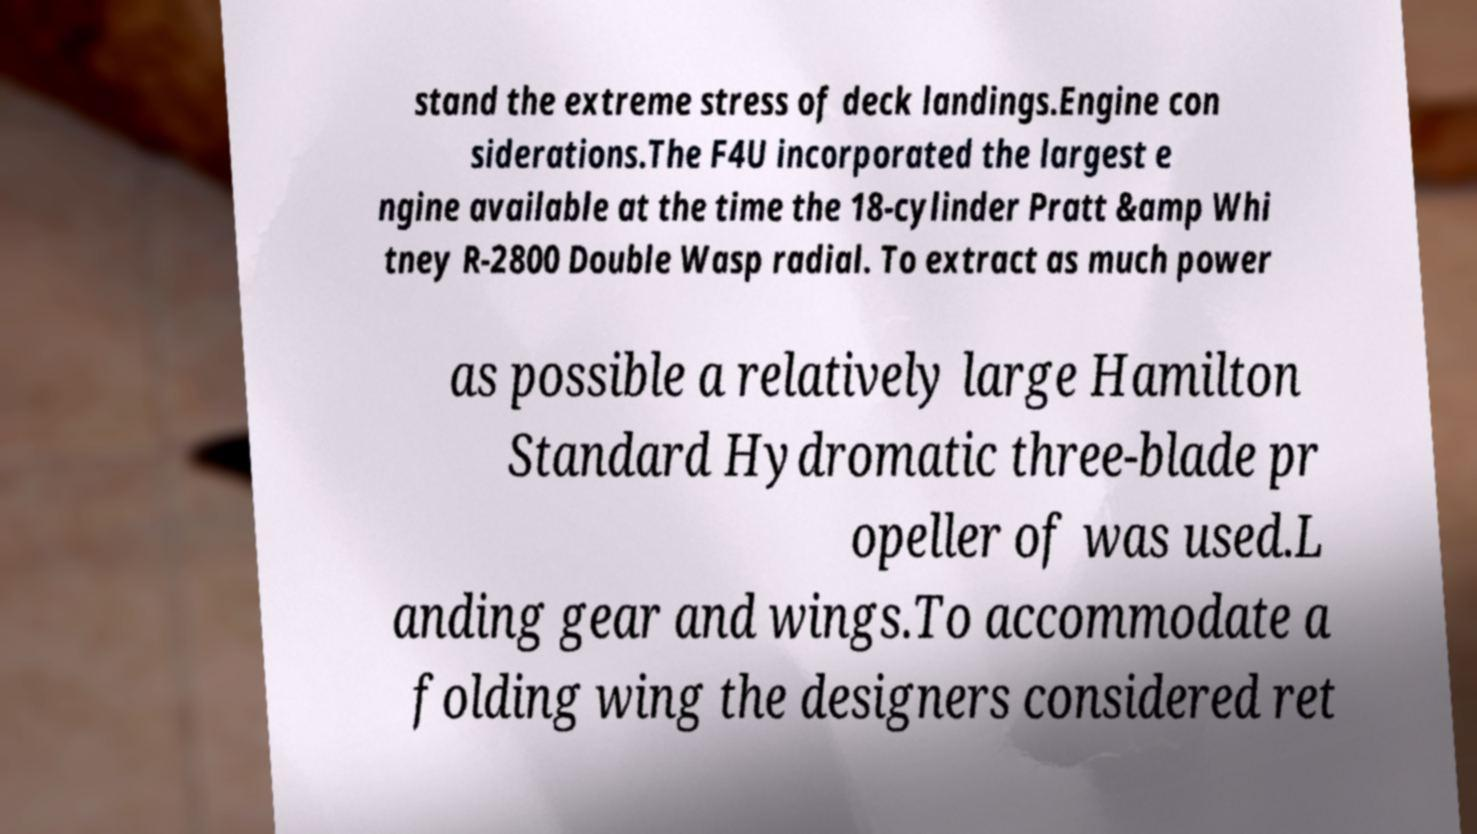There's text embedded in this image that I need extracted. Can you transcribe it verbatim? stand the extreme stress of deck landings.Engine con siderations.The F4U incorporated the largest e ngine available at the time the 18-cylinder Pratt &amp Whi tney R-2800 Double Wasp radial. To extract as much power as possible a relatively large Hamilton Standard Hydromatic three-blade pr opeller of was used.L anding gear and wings.To accommodate a folding wing the designers considered ret 